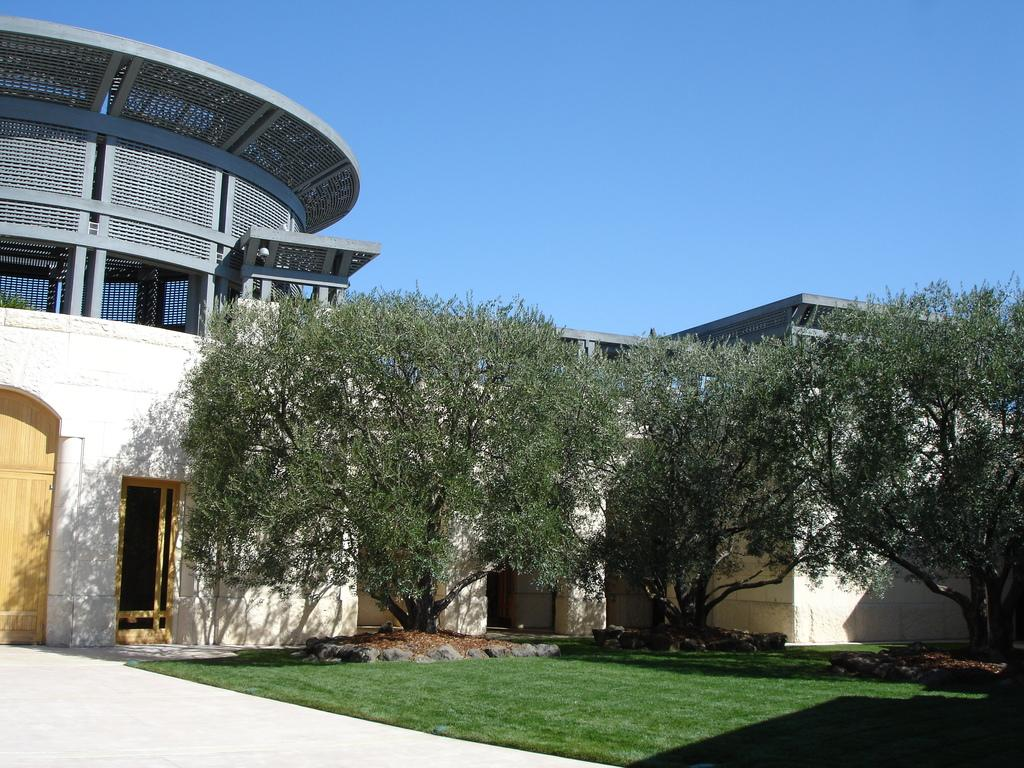What type of vegetation can be seen in the image? There is grass in the image. What other natural elements are present in the image? There are trees in the image. What type of man-made structures can be seen in the image? There are buildings in the image. What architectural features can be seen on the buildings? There are doors in the image. What material is used for the rods in the image? There are metal rods in the image. What part of the natural environment is visible in the image? The sky is visible in the image. Based on the visibility of the sky and the presence of natural light, when do you think the image was taken? The image was likely taken during the day. What type of net is used to catch the brain in the image? There is no net or brain present in the image. What type of roof is visible on the buildings in the image? The image does not show the roofs of the buildings, only the doors. 